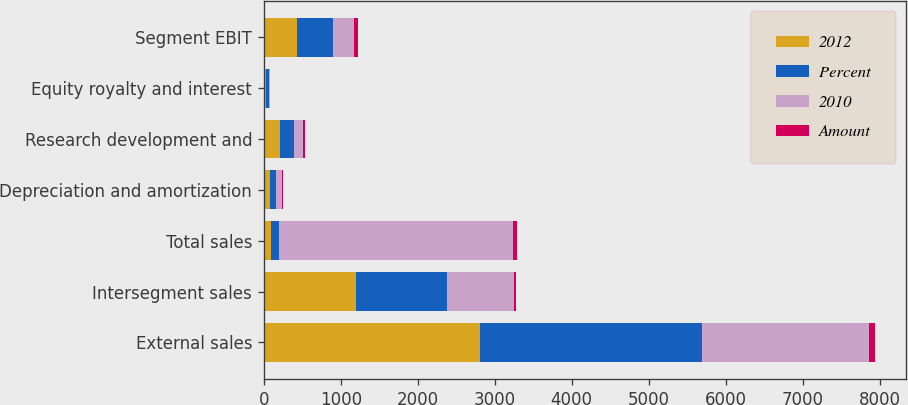Convert chart to OTSL. <chart><loc_0><loc_0><loc_500><loc_500><stacked_bar_chart><ecel><fcel>External sales<fcel>Intersegment sales<fcel>Total sales<fcel>Depreciation and amortization<fcel>Research development and<fcel>Equity royalty and interest<fcel>Segment EBIT<nl><fcel>2012<fcel>2809<fcel>1203<fcel>98<fcel>82<fcel>213<fcel>29<fcel>426<nl><fcel>Percent<fcel>2886<fcel>1177<fcel>98<fcel>73<fcel>175<fcel>31<fcel>470<nl><fcel>2010<fcel>2171<fcel>875<fcel>3046<fcel>79<fcel>114<fcel>23<fcel>278<nl><fcel>Amount<fcel>77<fcel>26<fcel>51<fcel>9<fcel>38<fcel>2<fcel>44<nl></chart> 